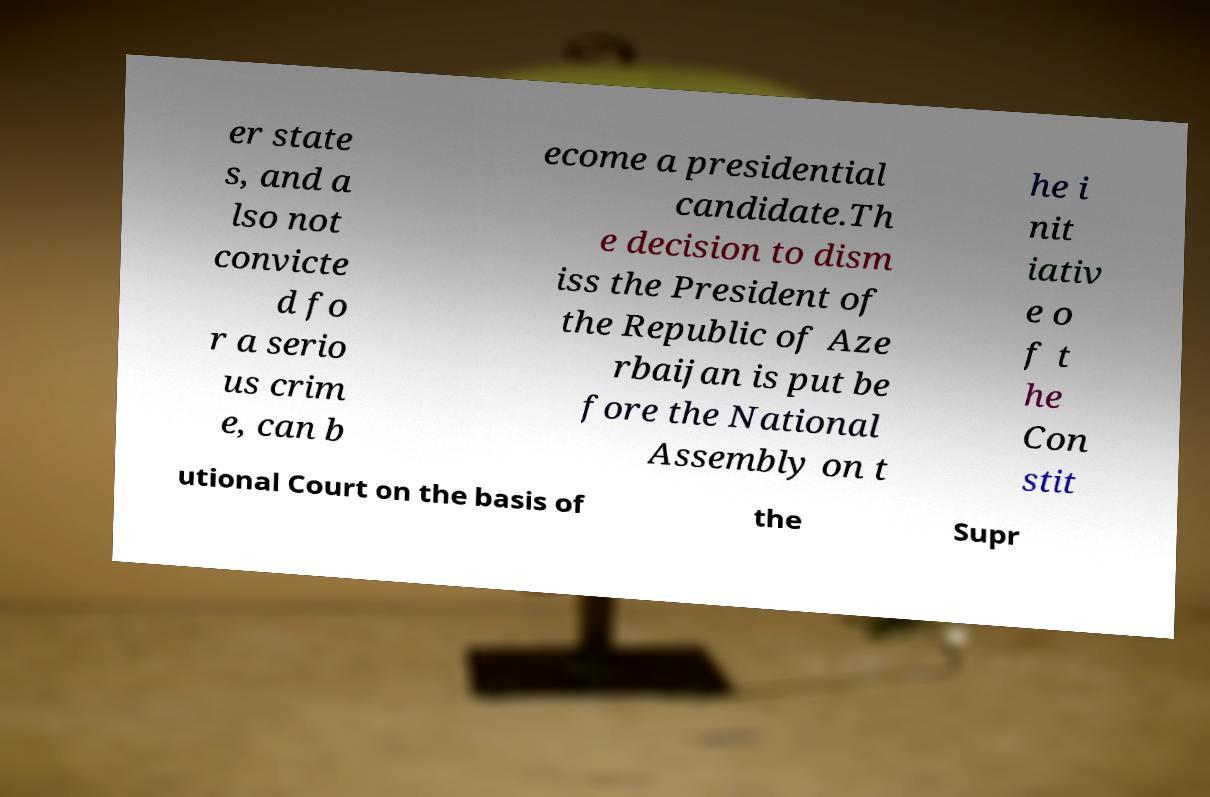Please read and relay the text visible in this image. What does it say? er state s, and a lso not convicte d fo r a serio us crim e, can b ecome a presidential candidate.Th e decision to dism iss the President of the Republic of Aze rbaijan is put be fore the National Assembly on t he i nit iativ e o f t he Con stit utional Court on the basis of the Supr 